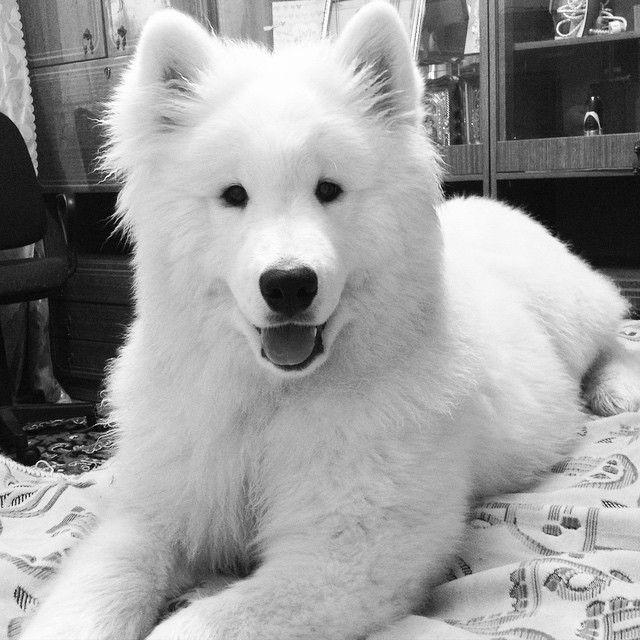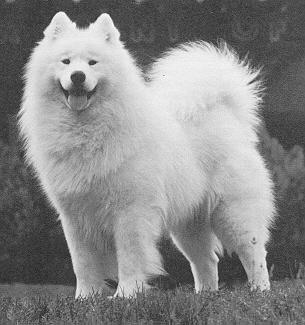The first image is the image on the left, the second image is the image on the right. Examine the images to the left and right. Is the description "One of the images features two dogs side by side." accurate? Answer yes or no. No. The first image is the image on the left, the second image is the image on the right. Examine the images to the left and right. Is the description "Only white dogs are shown and no image contains more than one dog, and one image shows a white non-standing dog with front paws forward." accurate? Answer yes or no. Yes. 